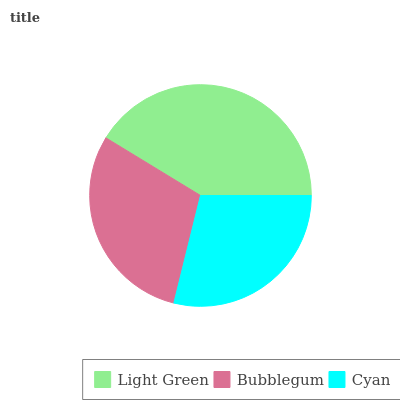Is Cyan the minimum?
Answer yes or no. Yes. Is Light Green the maximum?
Answer yes or no. Yes. Is Bubblegum the minimum?
Answer yes or no. No. Is Bubblegum the maximum?
Answer yes or no. No. Is Light Green greater than Bubblegum?
Answer yes or no. Yes. Is Bubblegum less than Light Green?
Answer yes or no. Yes. Is Bubblegum greater than Light Green?
Answer yes or no. No. Is Light Green less than Bubblegum?
Answer yes or no. No. Is Bubblegum the high median?
Answer yes or no. Yes. Is Bubblegum the low median?
Answer yes or no. Yes. Is Light Green the high median?
Answer yes or no. No. Is Light Green the low median?
Answer yes or no. No. 